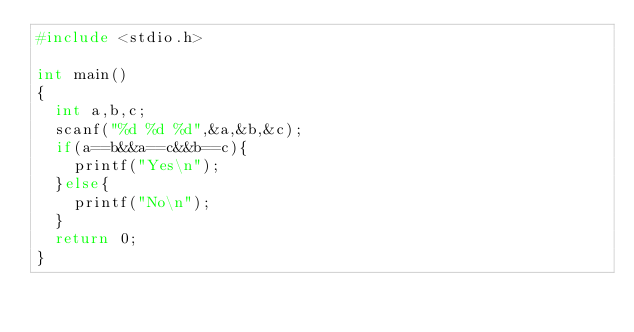<code> <loc_0><loc_0><loc_500><loc_500><_C_>#include <stdio.h>

int main()
{
	int a,b,c;
	scanf("%d %d %d",&a,&b,&c);
	if(a==b&&a==c&&b==c){
		printf("Yes\n");
	}else{
		printf("No\n");
	}
	return 0;
}
</code> 